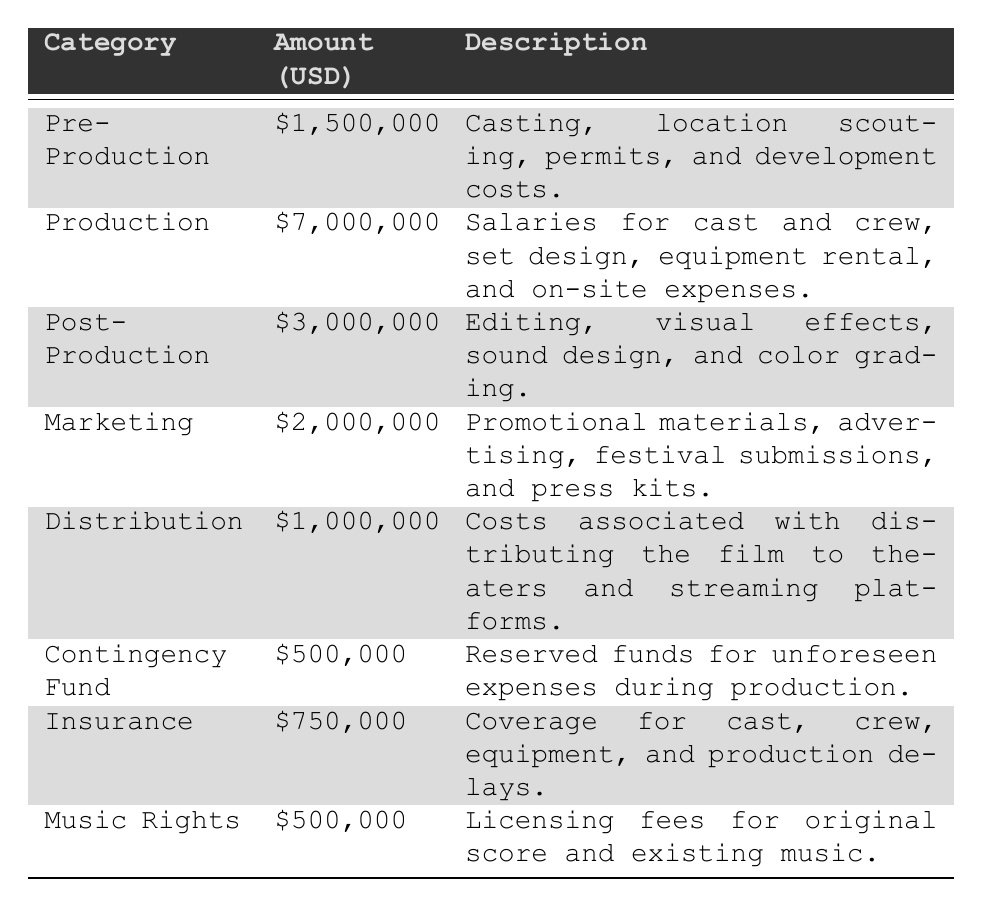What is the total budget allocated for Production? The table shows that the amount allocated for Production is $7,000,000.
Answer: $7,000,000 How much is allocated to Marketing and Distribution combined? Adding the amounts for Marketing ($2,000,000) and Distribution ($1,000,000) gives a total of $3,000,000.
Answer: $3,000,000 Is the budget for Post-Production greater than the budget for Insurance? The Post-Production budget is $3,000,000, and the Insurance budget is $750,000. Since $3,000,000 is greater than $750,000, the answer is yes.
Answer: Yes What percentage of the total budget is allocated for Pre-Production? The total budget is $15,000,000 (sum of all categories). The Pre-Production budget is $1,500,000. The percentage is calculated as ($1,500,000 / $15,000,000) * 100 = 10%.
Answer: 10% What is the difference in budget between Production and Marketing? The Production budget is $7,000,000, and the Marketing budget is $2,000,000. The difference is $7,000,000 - $2,000,000 = $5,000,000.
Answer: $5,000,000 How much of the budget is spent on contingencies compared to Music Rights? The Contingency Fund is $500,000 and Music Rights is also $500,000. Since they are equal, the amount spent on both is the same.
Answer: They are equal What are the total costs allocated for all production categories excluding Insurance and Music Rights? The total costs for all categories are $15,000,000. Excluding Insurance ($750,000) and Music Rights ($500,000) gives $15,000,000 - $750,000 - $500,000 = $13,750,000.
Answer: $13,750,000 Which production category has the highest budget and what is that amount? The category with the highest budget is Production, with an allocation of $7,000,000.
Answer: $7,000,000 If we were to evenly distribute the amount for Post-Production across all days of production assuming a 30-day shooting schedule, how much would be allocated per day? The Post-Production budget is $3,000,000. Dividing this by 30 days gives $3,000,000 / 30 = $100,000 per day.
Answer: $100,000 How does the amount allocated for Distribution compare to the total allocated for Pre-Production and Contingency Fund combined? The Distribution budget is $1,000,000. The Pre-Production amount is $1,500,000 and Contingency Fund is $500,000, totaling $2,000,000. Since $1,000,000 is less than $2,000,000, it is lower.
Answer: It is lower 